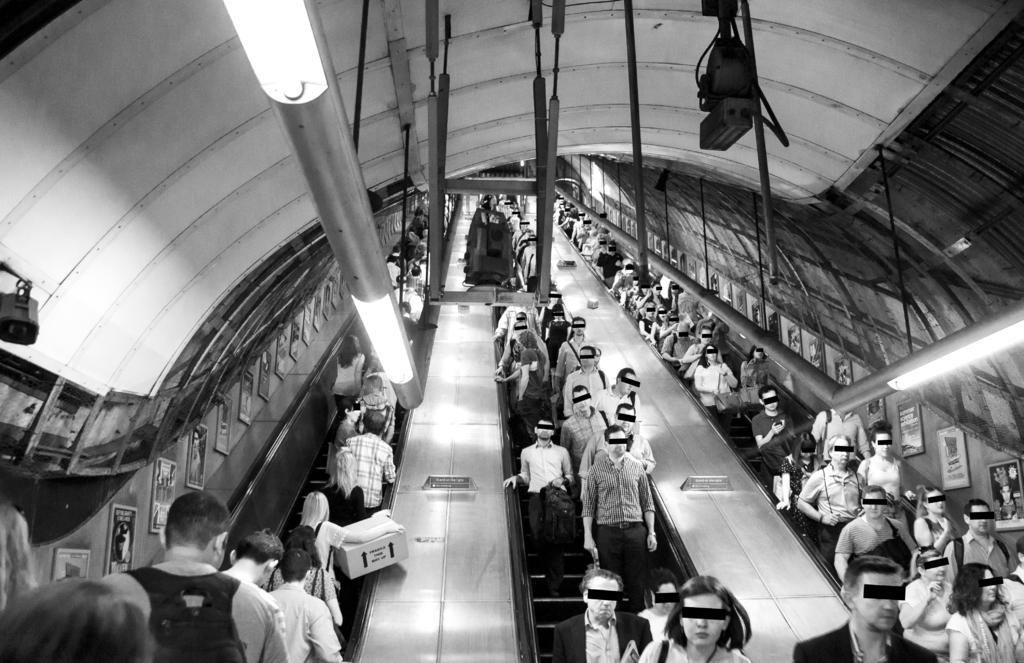Describe this image in one or two sentences. This picture is a black and white image. In this image we can see the Subway with Escalators, some people are standing on the escalators, few people are walking, some people are wearing bags, some people are holding objects, some frames with text and images attached to the escalator walls, few objects on the escalator, a few lights and some objects attached to the ceiling. One object on the left side of the image. 